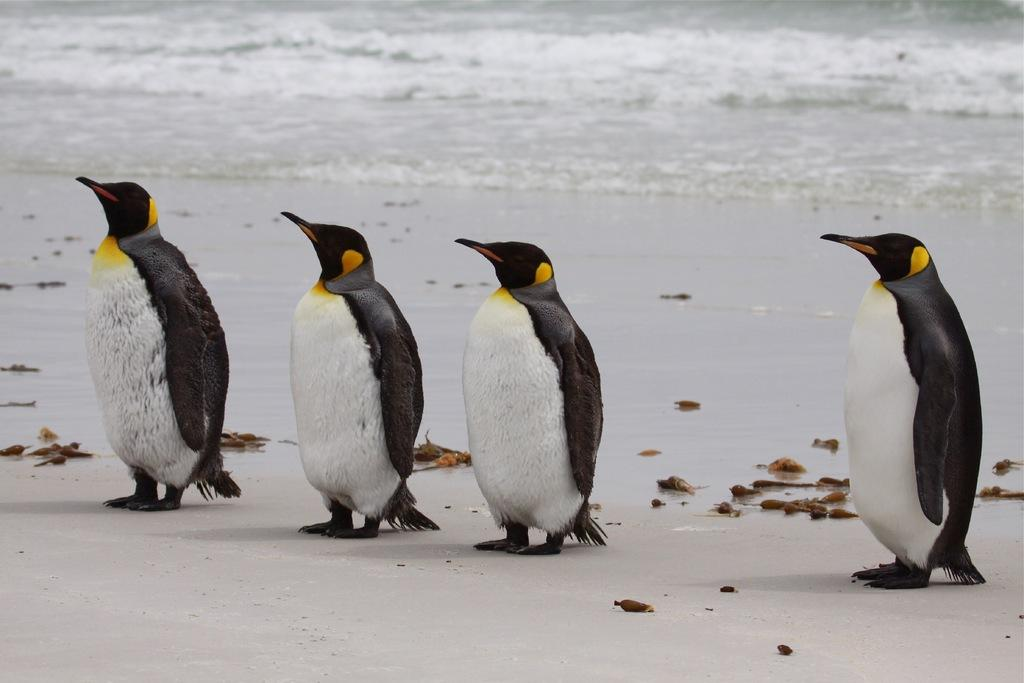How many penguins are in the image? There are four penguins in the image. Where are the penguins located in the image? The penguins are standing on the seashore. What can be seen in the background of the image? There is water visible in the background of the image. How many girls are present in the image? There are no girls present in the image; it features four penguins on the seashore. Is there a door visible in the image? There is no door present in the image. 